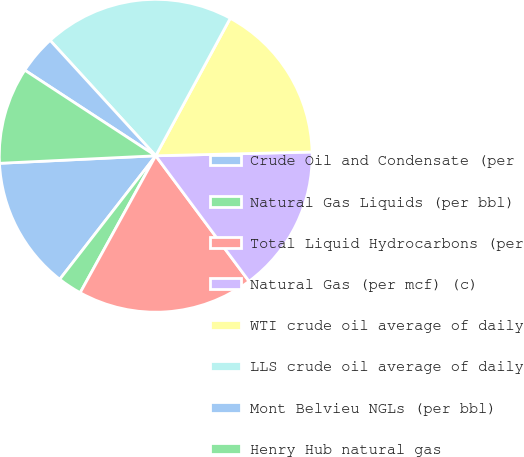Convert chart. <chart><loc_0><loc_0><loc_500><loc_500><pie_chart><fcel>Crude Oil and Condensate (per<fcel>Natural Gas Liquids (per bbl)<fcel>Total Liquid Hydrocarbons (per<fcel>Natural Gas (per mcf) (c)<fcel>WTI crude oil average of daily<fcel>LLS crude oil average of daily<fcel>Mont Belvieu NGLs (per bbl)<fcel>Henry Hub natural gas<nl><fcel>13.72%<fcel>2.49%<fcel>18.2%<fcel>15.21%<fcel>16.71%<fcel>19.7%<fcel>3.99%<fcel>9.98%<nl></chart> 